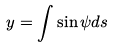<formula> <loc_0><loc_0><loc_500><loc_500>y = \int \sin \psi d s</formula> 